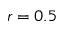<formula> <loc_0><loc_0><loc_500><loc_500>r = 0 . 5</formula> 